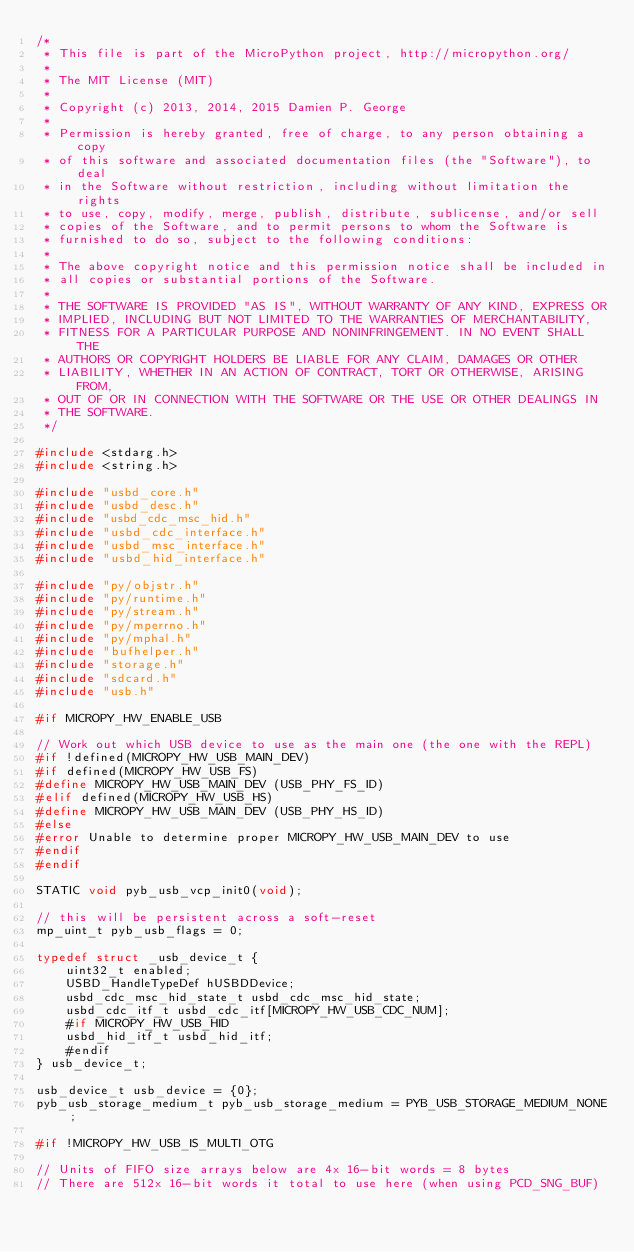<code> <loc_0><loc_0><loc_500><loc_500><_C_>/*
 * This file is part of the MicroPython project, http://micropython.org/
 *
 * The MIT License (MIT)
 *
 * Copyright (c) 2013, 2014, 2015 Damien P. George
 *
 * Permission is hereby granted, free of charge, to any person obtaining a copy
 * of this software and associated documentation files (the "Software"), to deal
 * in the Software without restriction, including without limitation the rights
 * to use, copy, modify, merge, publish, distribute, sublicense, and/or sell
 * copies of the Software, and to permit persons to whom the Software is
 * furnished to do so, subject to the following conditions:
 *
 * The above copyright notice and this permission notice shall be included in
 * all copies or substantial portions of the Software.
 *
 * THE SOFTWARE IS PROVIDED "AS IS", WITHOUT WARRANTY OF ANY KIND, EXPRESS OR
 * IMPLIED, INCLUDING BUT NOT LIMITED TO THE WARRANTIES OF MERCHANTABILITY,
 * FITNESS FOR A PARTICULAR PURPOSE AND NONINFRINGEMENT. IN NO EVENT SHALL THE
 * AUTHORS OR COPYRIGHT HOLDERS BE LIABLE FOR ANY CLAIM, DAMAGES OR OTHER
 * LIABILITY, WHETHER IN AN ACTION OF CONTRACT, TORT OR OTHERWISE, ARISING FROM,
 * OUT OF OR IN CONNECTION WITH THE SOFTWARE OR THE USE OR OTHER DEALINGS IN
 * THE SOFTWARE.
 */

#include <stdarg.h>
#include <string.h>

#include "usbd_core.h"
#include "usbd_desc.h"
#include "usbd_cdc_msc_hid.h"
#include "usbd_cdc_interface.h"
#include "usbd_msc_interface.h"
#include "usbd_hid_interface.h"

#include "py/objstr.h"
#include "py/runtime.h"
#include "py/stream.h"
#include "py/mperrno.h"
#include "py/mphal.h"
#include "bufhelper.h"
#include "storage.h"
#include "sdcard.h"
#include "usb.h"

#if MICROPY_HW_ENABLE_USB

// Work out which USB device to use as the main one (the one with the REPL)
#if !defined(MICROPY_HW_USB_MAIN_DEV)
#if defined(MICROPY_HW_USB_FS)
#define MICROPY_HW_USB_MAIN_DEV (USB_PHY_FS_ID)
#elif defined(MICROPY_HW_USB_HS)
#define MICROPY_HW_USB_MAIN_DEV (USB_PHY_HS_ID)
#else
#error Unable to determine proper MICROPY_HW_USB_MAIN_DEV to use
#endif
#endif

STATIC void pyb_usb_vcp_init0(void);

// this will be persistent across a soft-reset
mp_uint_t pyb_usb_flags = 0;

typedef struct _usb_device_t {
    uint32_t enabled;
    USBD_HandleTypeDef hUSBDDevice;
    usbd_cdc_msc_hid_state_t usbd_cdc_msc_hid_state;
    usbd_cdc_itf_t usbd_cdc_itf[MICROPY_HW_USB_CDC_NUM];
    #if MICROPY_HW_USB_HID
    usbd_hid_itf_t usbd_hid_itf;
    #endif
} usb_device_t;

usb_device_t usb_device = {0};
pyb_usb_storage_medium_t pyb_usb_storage_medium = PYB_USB_STORAGE_MEDIUM_NONE;

#if !MICROPY_HW_USB_IS_MULTI_OTG

// Units of FIFO size arrays below are 4x 16-bit words = 8 bytes
// There are 512x 16-bit words it total to use here (when using PCD_SNG_BUF)
</code> 